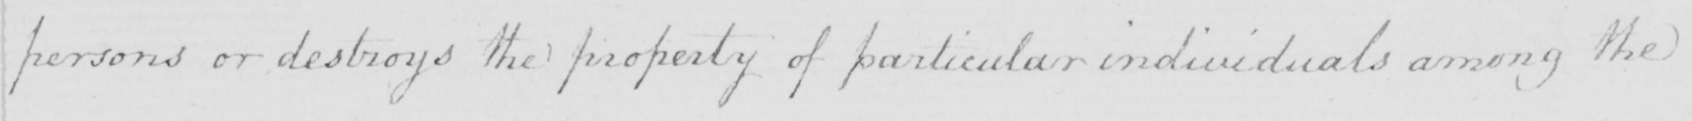What does this handwritten line say? persons or destroys the property of particular individuals among the 